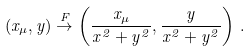Convert formula to latex. <formula><loc_0><loc_0><loc_500><loc_500>( x _ { \mu } , y ) \stackrel { F } { \rightarrow } \left ( \frac { x _ { \mu } } { x ^ { 2 } + y ^ { 2 } } , \frac { y } { x ^ { 2 } + y ^ { 2 } } \right ) \, .</formula> 